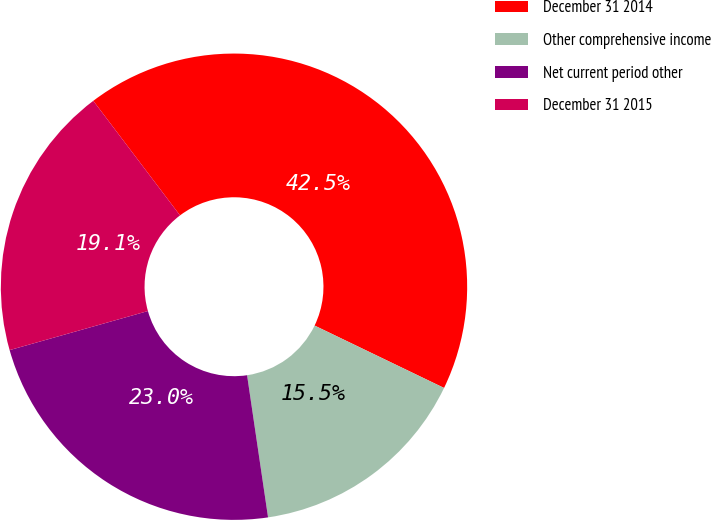Convert chart to OTSL. <chart><loc_0><loc_0><loc_500><loc_500><pie_chart><fcel>December 31 2014<fcel>Other comprehensive income<fcel>Net current period other<fcel>December 31 2015<nl><fcel>42.46%<fcel>15.52%<fcel>22.95%<fcel>19.07%<nl></chart> 